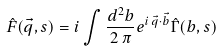Convert formula to latex. <formula><loc_0><loc_0><loc_500><loc_500>\hat { F } ( \vec { q } , s ) = i \int \frac { d ^ { 2 } b } { 2 \, \pi } e ^ { i \, \vec { q } \cdot \vec { b } } \hat { \Gamma } ( b , s )</formula> 